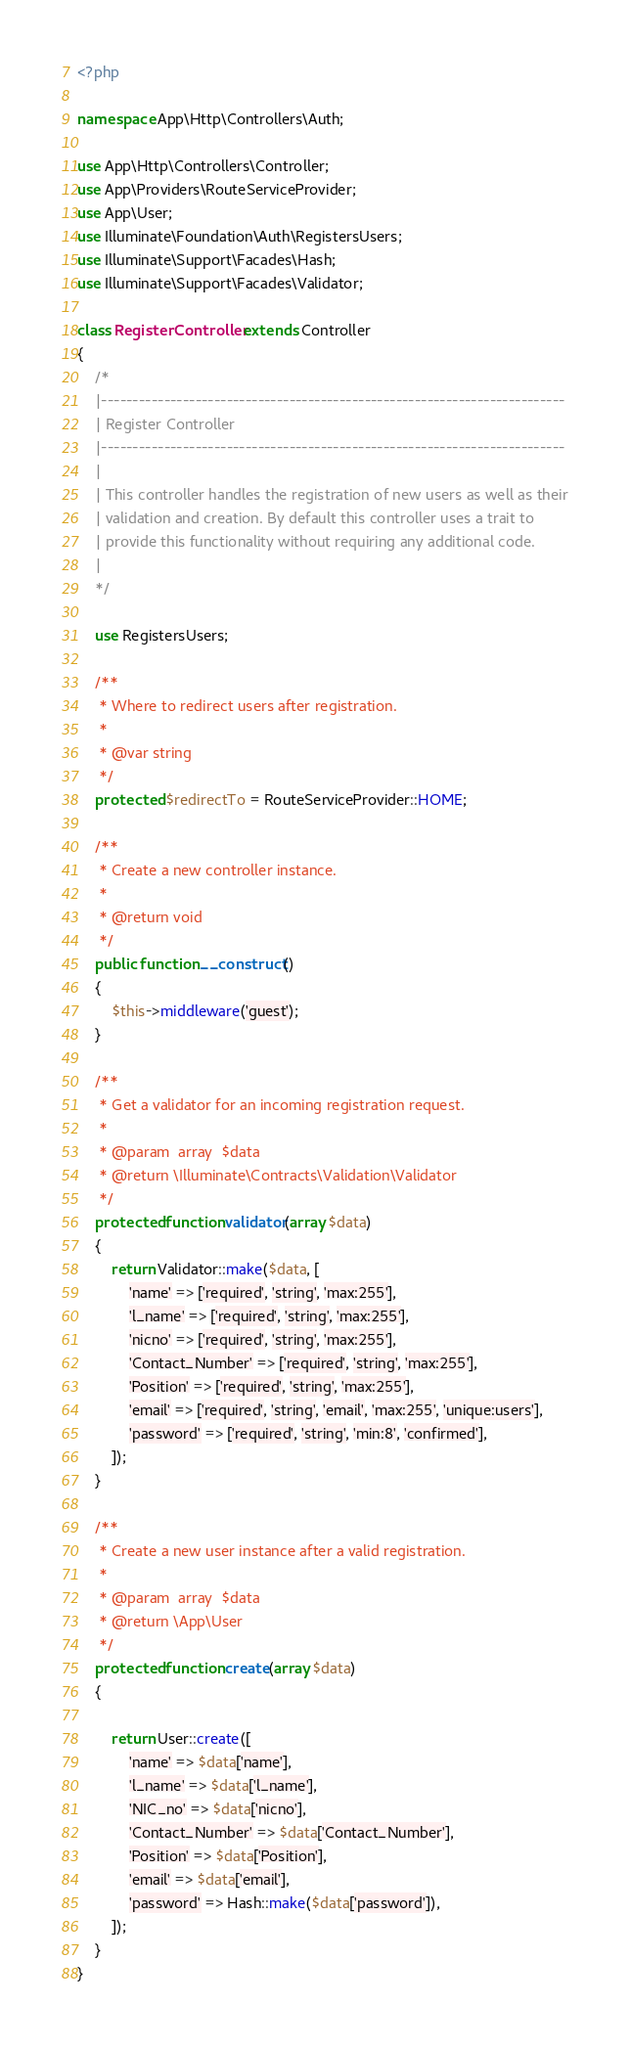<code> <loc_0><loc_0><loc_500><loc_500><_PHP_><?php

namespace App\Http\Controllers\Auth;

use App\Http\Controllers\Controller;
use App\Providers\RouteServiceProvider;
use App\User;
use Illuminate\Foundation\Auth\RegistersUsers;
use Illuminate\Support\Facades\Hash;
use Illuminate\Support\Facades\Validator;

class RegisterController extends Controller
{
    /*
    |--------------------------------------------------------------------------
    | Register Controller
    |--------------------------------------------------------------------------
    |
    | This controller handles the registration of new users as well as their
    | validation and creation. By default this controller uses a trait to
    | provide this functionality without requiring any additional code.
    |
    */

    use RegistersUsers;

    /**
     * Where to redirect users after registration.
     *
     * @var string
     */
    protected $redirectTo = RouteServiceProvider::HOME;

    /**
     * Create a new controller instance.
     *
     * @return void
     */
    public function __construct()
    {
        $this->middleware('guest');
    }

    /**
     * Get a validator for an incoming registration request.
     *
     * @param  array  $data
     * @return \Illuminate\Contracts\Validation\Validator
     */
    protected function validator(array $data)
    {
        return Validator::make($data, [
            'name' => ['required', 'string', 'max:255'],
            'l_name' => ['required', 'string', 'max:255'],
            'nicno' => ['required', 'string', 'max:255'],
            'Contact_Number' => ['required', 'string', 'max:255'],
            'Position' => ['required', 'string', 'max:255'],
            'email' => ['required', 'string', 'email', 'max:255', 'unique:users'],
            'password' => ['required', 'string', 'min:8', 'confirmed'],
        ]);
    }

    /**
     * Create a new user instance after a valid registration.
     *
     * @param  array  $data
     * @return \App\User
     */
    protected function create(array $data)
    {
        
        return User::create([
            'name' => $data['name'],
            'l_name' => $data['l_name'],
            'NIC_no' => $data['nicno'],
            'Contact_Number' => $data['Contact_Number'],
            'Position' => $data['Position'],
            'email' => $data['email'],
            'password' => Hash::make($data['password']),
        ]);
    }
}
</code> 